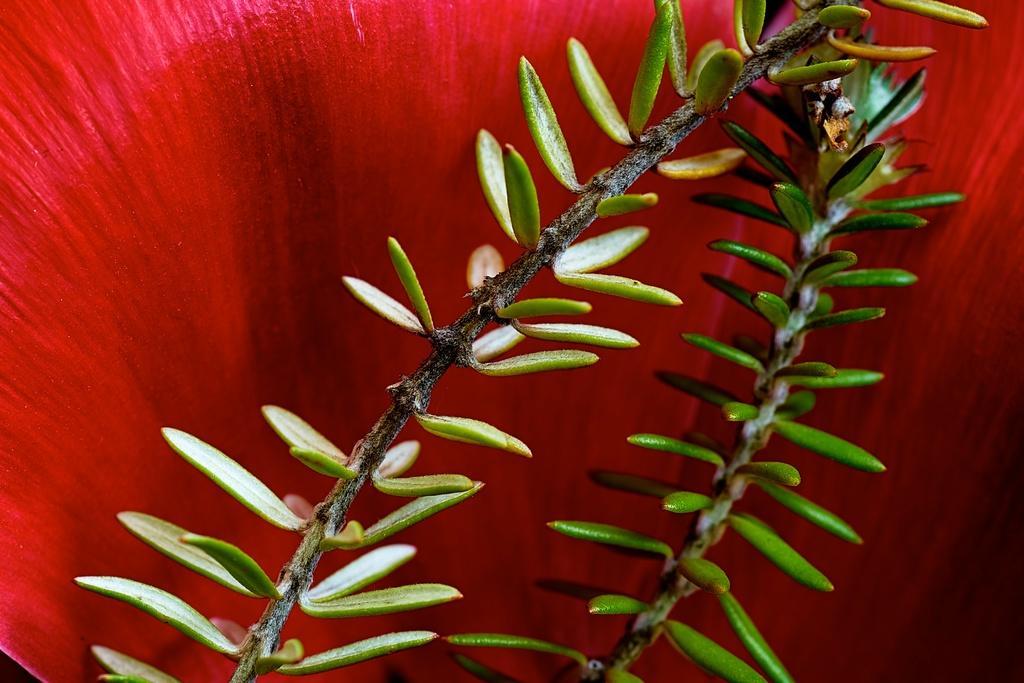Could you give a brief overview of what you see in this image? This is a zoomed in picture. In the center we can see the stem and the leaves. In the background there is a red color object. 